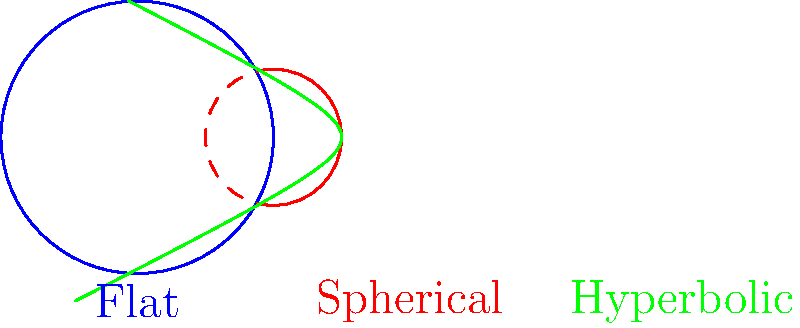In the context of Non-Euclidean Geometry, consider the circles drawn on flat, spherical, and hyperbolic geometries as shown in the diagram. How does the sum of interior angles of a triangle inscribed in these circles differ across these geometries, and what implications does this have for the concept of parallel lines? To understand the differences in the sum of interior angles of triangles inscribed in circles across flat, spherical, and hyperbolic geometries, let's examine each case:

1. Flat (Euclidean) geometry:
   - In Euclidean geometry, the sum of interior angles of any triangle is always 180°.
   - Parallel lines maintain a constant distance from each other and never intersect.

2. Spherical geometry:
   - On a sphere, the sum of interior angles of a triangle is always greater than 180°.
   - As the size of the triangle increases, the sum of its angles approaches 540° (3 * 180°).
   - There are no parallel lines on a sphere; all great circles (the equivalent of straight lines) intersect.

3. Hyperbolic geometry:
   - In hyperbolic space, the sum of interior angles of a triangle is always less than 180°.
   - As the size of the triangle increases, the sum of its angles approaches 0°.
   - There are infinitely many lines parallel to a given line through a point not on that line.

Implications for parallel lines:
- In Euclidean geometry, parallel lines are well-defined and maintain a constant distance.
- In spherical geometry, the concept of parallel lines doesn't exist as all great circles eventually intersect.
- In hyperbolic geometry, there are multiple lines through a point that never intersect a given line, leading to a more complex notion of parallelism.

These differences challenge our intuitive understanding of space and have profound implications for the nature of geometry and the universe itself, which aligns with the Marxist notion of dialectical materialism and the interconnectedness of all things.
Answer: Flat: 180°, unique parallels; Spherical: >180°, no parallels; Hyperbolic: <180°, multiple parallels. 